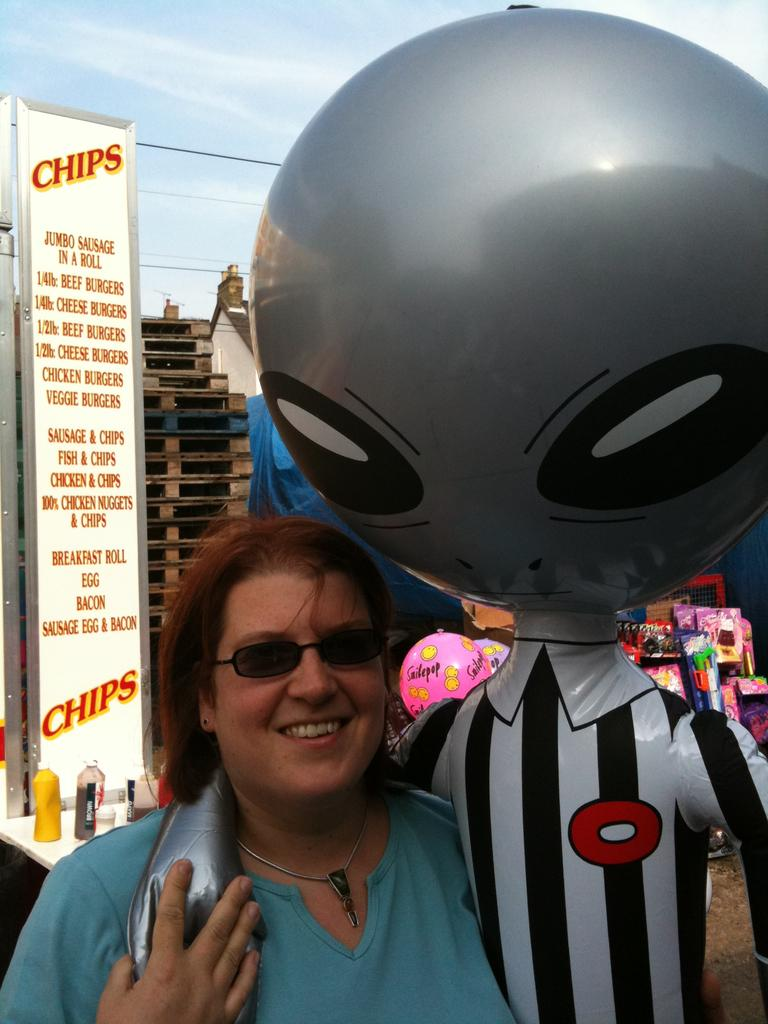What is one of the main objects in the image? There is a balloon in the image. What other object can be seen in the image? There is a statue in the image. Who is present in the image? There is a woman standing in the front of the image. What is hanging or displayed in the image? There is a banner in the image. What can be seen at the top of the image? The sky is visible at the top of the image. What type of powder is being used to clean the statue in the image? There is no powder or cleaning activity depicted in the image; it only shows a balloon, a statue, a woman, a banner, and the sky. 